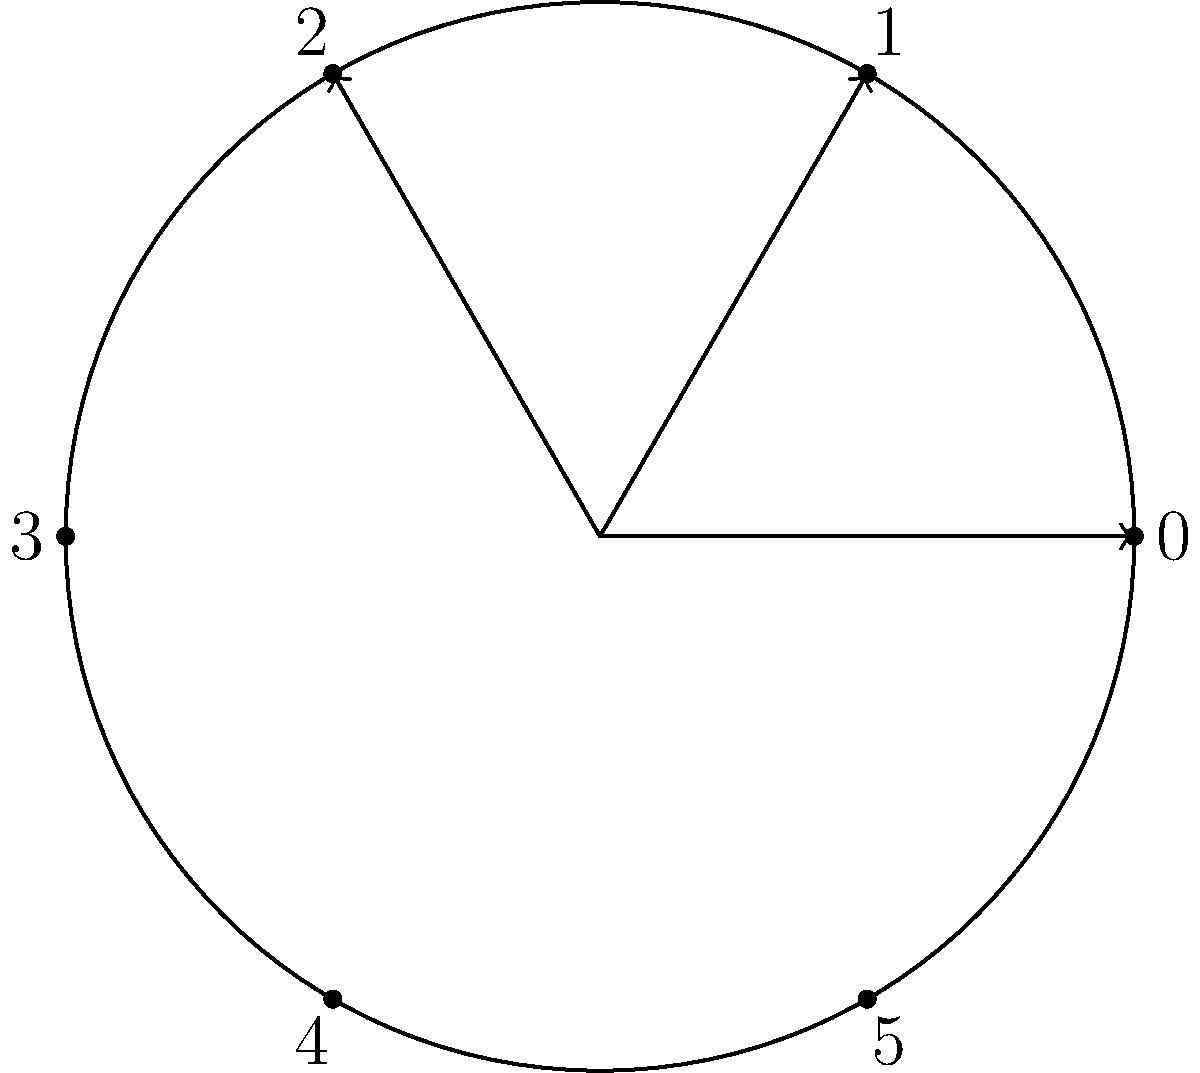Consider the cyclic group $C_6 = \{0, 1, 2, 3, 4, 5\}$ under addition modulo 6. The cosets of the subgroup $H = \{0, 3\}$ are represented in the circular diagram above. If we rotate the diagram by 120° clockwise, which element will be at the top position? Let's approach this step-by-step:

1) First, we need to understand what the diagram represents:
   - The circle represents the cyclic group $C_6$.
   - Each point on the circle represents an element of the group.
   - The arrows indicate the direction of rotation.

2) The subgroup $H = \{0, 3\}$ divides $C_6$ into three cosets:
   - $H = \{0, 3\}$
   - $1 + H = \{1, 4\}$
   - $2 + H = \{2, 5\}$

3) In the current diagram, 0 is at the top position.

4) A 120° clockwise rotation is equivalent to moving 2 positions clockwise.

5) Starting from 0 and moving 2 positions clockwise, we land on 2.

6) Therefore, after a 120° clockwise rotation, 2 will be at the top position.

This problem relates to the persona of a graduate student studying late into the night, as it requires careful consideration and visualization, which are often clearer in the quiet, peaceful environment of late-night study.
Answer: 2 